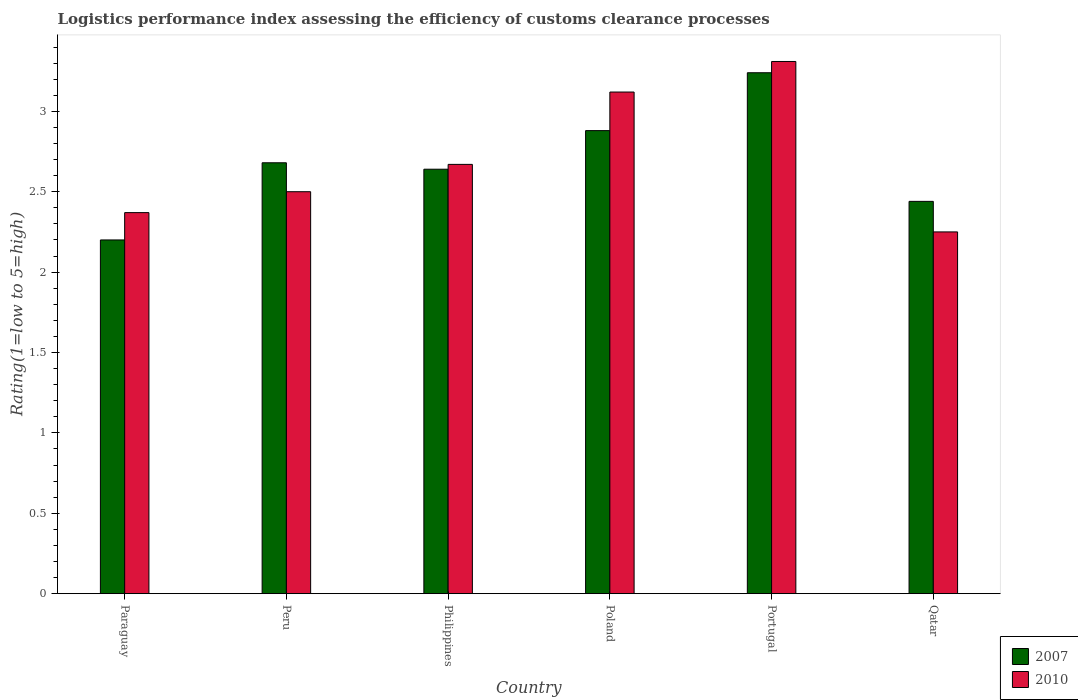How many different coloured bars are there?
Your answer should be very brief. 2. Are the number of bars on each tick of the X-axis equal?
Your response must be concise. Yes. How many bars are there on the 6th tick from the left?
Offer a very short reply. 2. What is the label of the 6th group of bars from the left?
Offer a terse response. Qatar. In how many cases, is the number of bars for a given country not equal to the number of legend labels?
Your response must be concise. 0. What is the Logistic performance index in 2010 in Qatar?
Your answer should be compact. 2.25. Across all countries, what is the maximum Logistic performance index in 2010?
Keep it short and to the point. 3.31. In which country was the Logistic performance index in 2010 maximum?
Make the answer very short. Portugal. In which country was the Logistic performance index in 2010 minimum?
Your answer should be compact. Qatar. What is the total Logistic performance index in 2010 in the graph?
Offer a very short reply. 16.22. What is the difference between the Logistic performance index in 2010 in Paraguay and that in Peru?
Your response must be concise. -0.13. What is the difference between the Logistic performance index in 2007 in Poland and the Logistic performance index in 2010 in Peru?
Your answer should be very brief. 0.38. What is the average Logistic performance index in 2007 per country?
Make the answer very short. 2.68. What is the difference between the Logistic performance index of/in 2010 and Logistic performance index of/in 2007 in Qatar?
Ensure brevity in your answer.  -0.19. What is the ratio of the Logistic performance index in 2010 in Peru to that in Philippines?
Ensure brevity in your answer.  0.94. Is the Logistic performance index in 2007 in Paraguay less than that in Portugal?
Offer a terse response. Yes. What is the difference between the highest and the second highest Logistic performance index in 2007?
Make the answer very short. -0.2. What is the difference between the highest and the lowest Logistic performance index in 2007?
Offer a terse response. 1.04. In how many countries, is the Logistic performance index in 2010 greater than the average Logistic performance index in 2010 taken over all countries?
Make the answer very short. 2. What does the 1st bar from the right in Qatar represents?
Your answer should be very brief. 2010. Are all the bars in the graph horizontal?
Ensure brevity in your answer.  No. How many countries are there in the graph?
Provide a succinct answer. 6. What is the difference between two consecutive major ticks on the Y-axis?
Your response must be concise. 0.5. Are the values on the major ticks of Y-axis written in scientific E-notation?
Offer a very short reply. No. What is the title of the graph?
Ensure brevity in your answer.  Logistics performance index assessing the efficiency of customs clearance processes. Does "1975" appear as one of the legend labels in the graph?
Provide a succinct answer. No. What is the label or title of the X-axis?
Give a very brief answer. Country. What is the label or title of the Y-axis?
Offer a very short reply. Rating(1=low to 5=high). What is the Rating(1=low to 5=high) in 2007 in Paraguay?
Make the answer very short. 2.2. What is the Rating(1=low to 5=high) of 2010 in Paraguay?
Give a very brief answer. 2.37. What is the Rating(1=low to 5=high) of 2007 in Peru?
Provide a succinct answer. 2.68. What is the Rating(1=low to 5=high) in 2010 in Peru?
Make the answer very short. 2.5. What is the Rating(1=low to 5=high) of 2007 in Philippines?
Give a very brief answer. 2.64. What is the Rating(1=low to 5=high) in 2010 in Philippines?
Give a very brief answer. 2.67. What is the Rating(1=low to 5=high) of 2007 in Poland?
Give a very brief answer. 2.88. What is the Rating(1=low to 5=high) of 2010 in Poland?
Make the answer very short. 3.12. What is the Rating(1=low to 5=high) in 2007 in Portugal?
Offer a very short reply. 3.24. What is the Rating(1=low to 5=high) of 2010 in Portugal?
Your response must be concise. 3.31. What is the Rating(1=low to 5=high) in 2007 in Qatar?
Provide a short and direct response. 2.44. What is the Rating(1=low to 5=high) of 2010 in Qatar?
Provide a short and direct response. 2.25. Across all countries, what is the maximum Rating(1=low to 5=high) of 2007?
Keep it short and to the point. 3.24. Across all countries, what is the maximum Rating(1=low to 5=high) of 2010?
Provide a succinct answer. 3.31. Across all countries, what is the minimum Rating(1=low to 5=high) of 2007?
Ensure brevity in your answer.  2.2. Across all countries, what is the minimum Rating(1=low to 5=high) in 2010?
Provide a succinct answer. 2.25. What is the total Rating(1=low to 5=high) of 2007 in the graph?
Provide a succinct answer. 16.08. What is the total Rating(1=low to 5=high) in 2010 in the graph?
Your answer should be very brief. 16.22. What is the difference between the Rating(1=low to 5=high) in 2007 in Paraguay and that in Peru?
Your response must be concise. -0.48. What is the difference between the Rating(1=low to 5=high) in 2010 in Paraguay and that in Peru?
Provide a short and direct response. -0.13. What is the difference between the Rating(1=low to 5=high) of 2007 in Paraguay and that in Philippines?
Offer a terse response. -0.44. What is the difference between the Rating(1=low to 5=high) in 2010 in Paraguay and that in Philippines?
Provide a short and direct response. -0.3. What is the difference between the Rating(1=low to 5=high) in 2007 in Paraguay and that in Poland?
Ensure brevity in your answer.  -0.68. What is the difference between the Rating(1=low to 5=high) in 2010 in Paraguay and that in Poland?
Provide a short and direct response. -0.75. What is the difference between the Rating(1=low to 5=high) in 2007 in Paraguay and that in Portugal?
Make the answer very short. -1.04. What is the difference between the Rating(1=low to 5=high) of 2010 in Paraguay and that in Portugal?
Keep it short and to the point. -0.94. What is the difference between the Rating(1=low to 5=high) in 2007 in Paraguay and that in Qatar?
Your response must be concise. -0.24. What is the difference between the Rating(1=low to 5=high) in 2010 in Paraguay and that in Qatar?
Provide a succinct answer. 0.12. What is the difference between the Rating(1=low to 5=high) of 2010 in Peru and that in Philippines?
Your answer should be compact. -0.17. What is the difference between the Rating(1=low to 5=high) in 2010 in Peru and that in Poland?
Keep it short and to the point. -0.62. What is the difference between the Rating(1=low to 5=high) of 2007 in Peru and that in Portugal?
Give a very brief answer. -0.56. What is the difference between the Rating(1=low to 5=high) in 2010 in Peru and that in Portugal?
Ensure brevity in your answer.  -0.81. What is the difference between the Rating(1=low to 5=high) of 2007 in Peru and that in Qatar?
Keep it short and to the point. 0.24. What is the difference between the Rating(1=low to 5=high) in 2007 in Philippines and that in Poland?
Give a very brief answer. -0.24. What is the difference between the Rating(1=low to 5=high) of 2010 in Philippines and that in Poland?
Provide a succinct answer. -0.45. What is the difference between the Rating(1=low to 5=high) of 2010 in Philippines and that in Portugal?
Make the answer very short. -0.64. What is the difference between the Rating(1=low to 5=high) of 2010 in Philippines and that in Qatar?
Your response must be concise. 0.42. What is the difference between the Rating(1=low to 5=high) in 2007 in Poland and that in Portugal?
Ensure brevity in your answer.  -0.36. What is the difference between the Rating(1=low to 5=high) of 2010 in Poland and that in Portugal?
Ensure brevity in your answer.  -0.19. What is the difference between the Rating(1=low to 5=high) of 2007 in Poland and that in Qatar?
Provide a short and direct response. 0.44. What is the difference between the Rating(1=low to 5=high) in 2010 in Poland and that in Qatar?
Ensure brevity in your answer.  0.87. What is the difference between the Rating(1=low to 5=high) of 2010 in Portugal and that in Qatar?
Keep it short and to the point. 1.06. What is the difference between the Rating(1=low to 5=high) of 2007 in Paraguay and the Rating(1=low to 5=high) of 2010 in Peru?
Your answer should be very brief. -0.3. What is the difference between the Rating(1=low to 5=high) in 2007 in Paraguay and the Rating(1=low to 5=high) in 2010 in Philippines?
Offer a very short reply. -0.47. What is the difference between the Rating(1=low to 5=high) in 2007 in Paraguay and the Rating(1=low to 5=high) in 2010 in Poland?
Provide a short and direct response. -0.92. What is the difference between the Rating(1=low to 5=high) in 2007 in Paraguay and the Rating(1=low to 5=high) in 2010 in Portugal?
Ensure brevity in your answer.  -1.11. What is the difference between the Rating(1=low to 5=high) in 2007 in Paraguay and the Rating(1=low to 5=high) in 2010 in Qatar?
Your answer should be very brief. -0.05. What is the difference between the Rating(1=low to 5=high) in 2007 in Peru and the Rating(1=low to 5=high) in 2010 in Philippines?
Ensure brevity in your answer.  0.01. What is the difference between the Rating(1=low to 5=high) in 2007 in Peru and the Rating(1=low to 5=high) in 2010 in Poland?
Ensure brevity in your answer.  -0.44. What is the difference between the Rating(1=low to 5=high) in 2007 in Peru and the Rating(1=low to 5=high) in 2010 in Portugal?
Provide a short and direct response. -0.63. What is the difference between the Rating(1=low to 5=high) of 2007 in Peru and the Rating(1=low to 5=high) of 2010 in Qatar?
Your response must be concise. 0.43. What is the difference between the Rating(1=low to 5=high) in 2007 in Philippines and the Rating(1=low to 5=high) in 2010 in Poland?
Offer a very short reply. -0.48. What is the difference between the Rating(1=low to 5=high) of 2007 in Philippines and the Rating(1=low to 5=high) of 2010 in Portugal?
Provide a short and direct response. -0.67. What is the difference between the Rating(1=low to 5=high) of 2007 in Philippines and the Rating(1=low to 5=high) of 2010 in Qatar?
Give a very brief answer. 0.39. What is the difference between the Rating(1=low to 5=high) of 2007 in Poland and the Rating(1=low to 5=high) of 2010 in Portugal?
Your answer should be compact. -0.43. What is the difference between the Rating(1=low to 5=high) in 2007 in Poland and the Rating(1=low to 5=high) in 2010 in Qatar?
Your response must be concise. 0.63. What is the average Rating(1=low to 5=high) in 2007 per country?
Your response must be concise. 2.68. What is the average Rating(1=low to 5=high) of 2010 per country?
Your answer should be very brief. 2.7. What is the difference between the Rating(1=low to 5=high) of 2007 and Rating(1=low to 5=high) of 2010 in Paraguay?
Your answer should be very brief. -0.17. What is the difference between the Rating(1=low to 5=high) of 2007 and Rating(1=low to 5=high) of 2010 in Peru?
Your answer should be compact. 0.18. What is the difference between the Rating(1=low to 5=high) in 2007 and Rating(1=low to 5=high) in 2010 in Philippines?
Ensure brevity in your answer.  -0.03. What is the difference between the Rating(1=low to 5=high) of 2007 and Rating(1=low to 5=high) of 2010 in Poland?
Offer a terse response. -0.24. What is the difference between the Rating(1=low to 5=high) in 2007 and Rating(1=low to 5=high) in 2010 in Portugal?
Your response must be concise. -0.07. What is the difference between the Rating(1=low to 5=high) in 2007 and Rating(1=low to 5=high) in 2010 in Qatar?
Offer a terse response. 0.19. What is the ratio of the Rating(1=low to 5=high) of 2007 in Paraguay to that in Peru?
Offer a very short reply. 0.82. What is the ratio of the Rating(1=low to 5=high) of 2010 in Paraguay to that in Peru?
Provide a succinct answer. 0.95. What is the ratio of the Rating(1=low to 5=high) in 2010 in Paraguay to that in Philippines?
Your response must be concise. 0.89. What is the ratio of the Rating(1=low to 5=high) in 2007 in Paraguay to that in Poland?
Provide a short and direct response. 0.76. What is the ratio of the Rating(1=low to 5=high) of 2010 in Paraguay to that in Poland?
Your response must be concise. 0.76. What is the ratio of the Rating(1=low to 5=high) in 2007 in Paraguay to that in Portugal?
Provide a short and direct response. 0.68. What is the ratio of the Rating(1=low to 5=high) in 2010 in Paraguay to that in Portugal?
Offer a very short reply. 0.72. What is the ratio of the Rating(1=low to 5=high) of 2007 in Paraguay to that in Qatar?
Make the answer very short. 0.9. What is the ratio of the Rating(1=low to 5=high) in 2010 in Paraguay to that in Qatar?
Offer a very short reply. 1.05. What is the ratio of the Rating(1=low to 5=high) in 2007 in Peru to that in Philippines?
Your response must be concise. 1.02. What is the ratio of the Rating(1=low to 5=high) of 2010 in Peru to that in Philippines?
Ensure brevity in your answer.  0.94. What is the ratio of the Rating(1=low to 5=high) in 2007 in Peru to that in Poland?
Offer a very short reply. 0.93. What is the ratio of the Rating(1=low to 5=high) of 2010 in Peru to that in Poland?
Provide a succinct answer. 0.8. What is the ratio of the Rating(1=low to 5=high) of 2007 in Peru to that in Portugal?
Give a very brief answer. 0.83. What is the ratio of the Rating(1=low to 5=high) of 2010 in Peru to that in Portugal?
Your response must be concise. 0.76. What is the ratio of the Rating(1=low to 5=high) of 2007 in Peru to that in Qatar?
Ensure brevity in your answer.  1.1. What is the ratio of the Rating(1=low to 5=high) in 2010 in Philippines to that in Poland?
Offer a terse response. 0.86. What is the ratio of the Rating(1=low to 5=high) of 2007 in Philippines to that in Portugal?
Give a very brief answer. 0.81. What is the ratio of the Rating(1=low to 5=high) in 2010 in Philippines to that in Portugal?
Offer a terse response. 0.81. What is the ratio of the Rating(1=low to 5=high) in 2007 in Philippines to that in Qatar?
Keep it short and to the point. 1.08. What is the ratio of the Rating(1=low to 5=high) of 2010 in Philippines to that in Qatar?
Keep it short and to the point. 1.19. What is the ratio of the Rating(1=low to 5=high) in 2010 in Poland to that in Portugal?
Provide a succinct answer. 0.94. What is the ratio of the Rating(1=low to 5=high) in 2007 in Poland to that in Qatar?
Make the answer very short. 1.18. What is the ratio of the Rating(1=low to 5=high) in 2010 in Poland to that in Qatar?
Give a very brief answer. 1.39. What is the ratio of the Rating(1=low to 5=high) of 2007 in Portugal to that in Qatar?
Your response must be concise. 1.33. What is the ratio of the Rating(1=low to 5=high) of 2010 in Portugal to that in Qatar?
Provide a succinct answer. 1.47. What is the difference between the highest and the second highest Rating(1=low to 5=high) of 2007?
Your answer should be very brief. 0.36. What is the difference between the highest and the second highest Rating(1=low to 5=high) of 2010?
Provide a succinct answer. 0.19. What is the difference between the highest and the lowest Rating(1=low to 5=high) of 2010?
Provide a short and direct response. 1.06. 